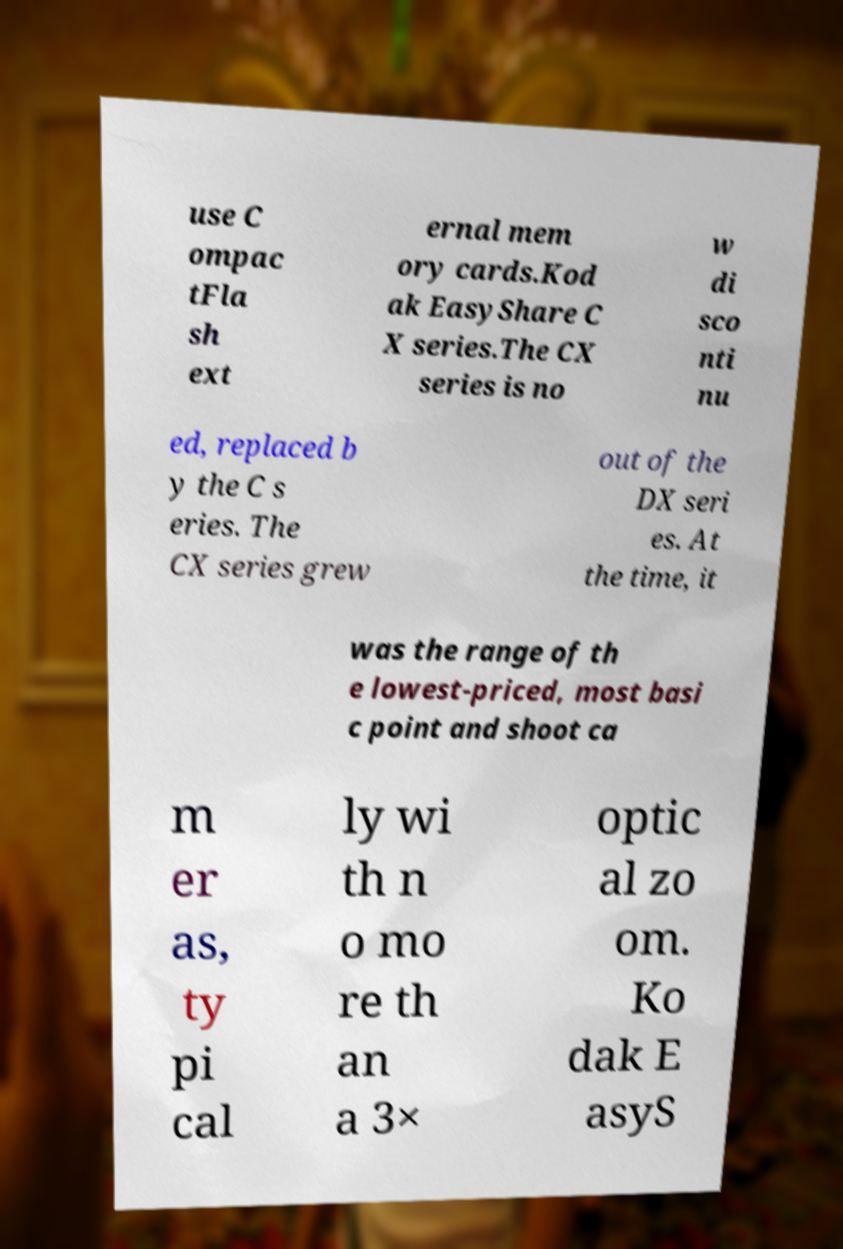Can you accurately transcribe the text from the provided image for me? use C ompac tFla sh ext ernal mem ory cards.Kod ak EasyShare C X series.The CX series is no w di sco nti nu ed, replaced b y the C s eries. The CX series grew out of the DX seri es. At the time, it was the range of th e lowest-priced, most basi c point and shoot ca m er as, ty pi cal ly wi th n o mo re th an a 3× optic al zo om. Ko dak E asyS 